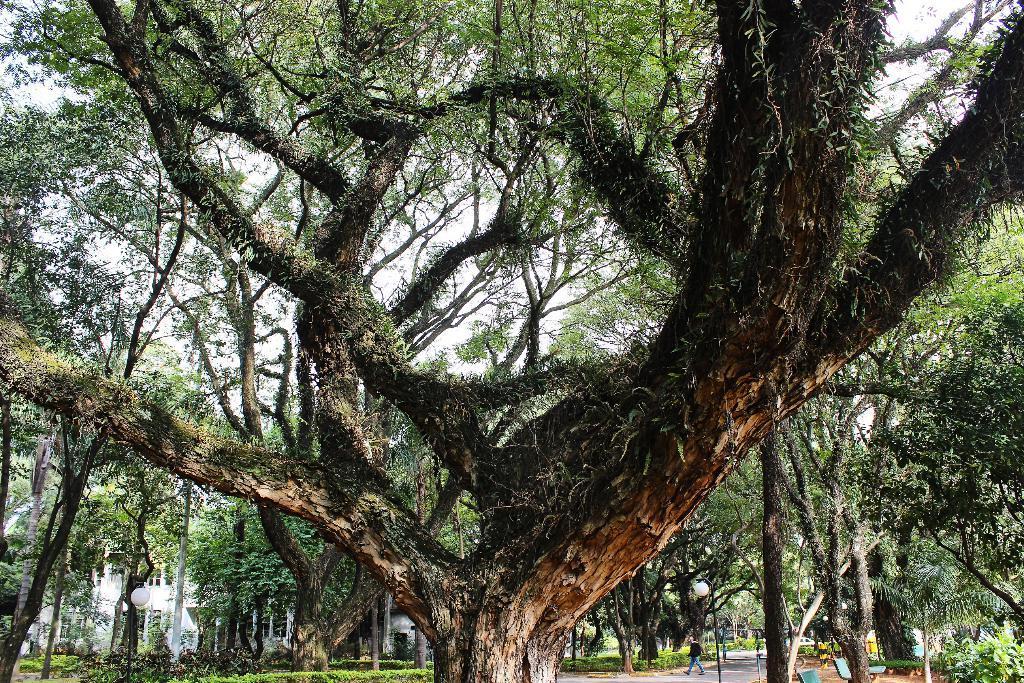Please provide a concise description of this image. In this image there are some trees as we can see in middle of this image. There is one building in the background and there is one person standing in the bottom right side of this image. 